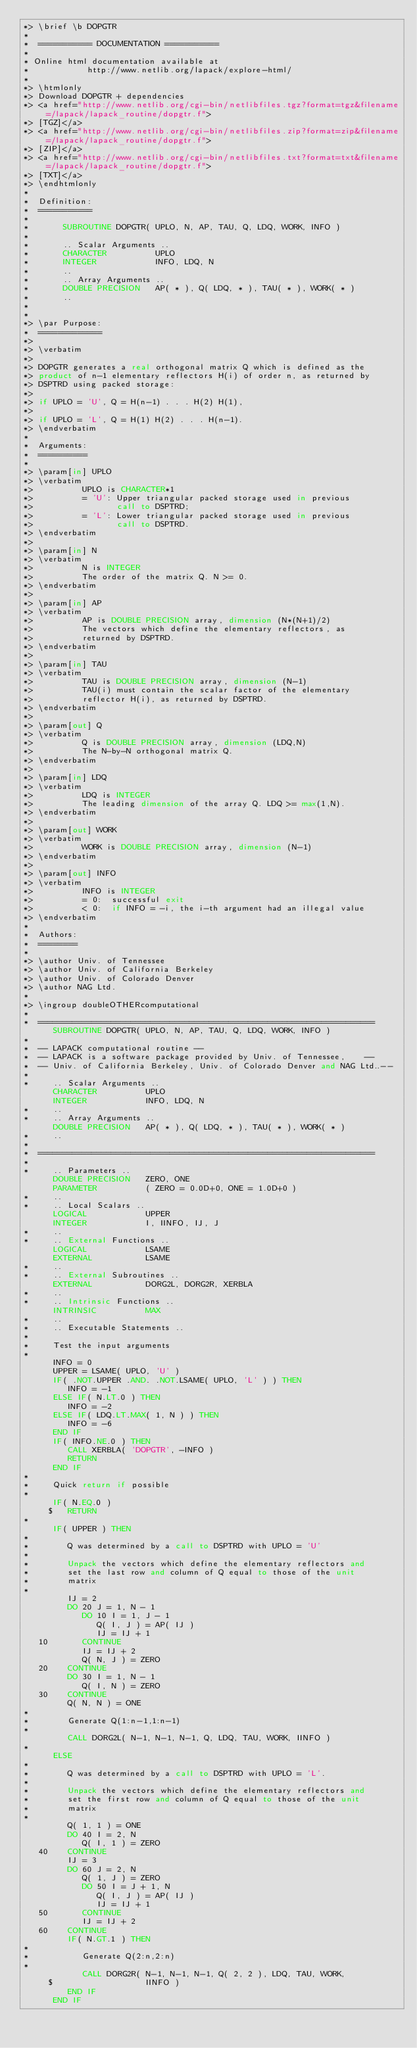Convert code to text. <code><loc_0><loc_0><loc_500><loc_500><_FORTRAN_>*> \brief \b DOPGTR
*
*  =========== DOCUMENTATION ===========
*
* Online html documentation available at
*            http://www.netlib.org/lapack/explore-html/
*
*> \htmlonly
*> Download DOPGTR + dependencies
*> <a href="http://www.netlib.org/cgi-bin/netlibfiles.tgz?format=tgz&filename=/lapack/lapack_routine/dopgtr.f">
*> [TGZ]</a>
*> <a href="http://www.netlib.org/cgi-bin/netlibfiles.zip?format=zip&filename=/lapack/lapack_routine/dopgtr.f">
*> [ZIP]</a>
*> <a href="http://www.netlib.org/cgi-bin/netlibfiles.txt?format=txt&filename=/lapack/lapack_routine/dopgtr.f">
*> [TXT]</a>
*> \endhtmlonly
*
*  Definition:
*  ===========
*
*       SUBROUTINE DOPGTR( UPLO, N, AP, TAU, Q, LDQ, WORK, INFO )
*
*       .. Scalar Arguments ..
*       CHARACTER          UPLO
*       INTEGER            INFO, LDQ, N
*       ..
*       .. Array Arguments ..
*       DOUBLE PRECISION   AP( * ), Q( LDQ, * ), TAU( * ), WORK( * )
*       ..
*
*
*> \par Purpose:
*  =============
*>
*> \verbatim
*>
*> DOPGTR generates a real orthogonal matrix Q which is defined as the
*> product of n-1 elementary reflectors H(i) of order n, as returned by
*> DSPTRD using packed storage:
*>
*> if UPLO = 'U', Q = H(n-1) . . . H(2) H(1),
*>
*> if UPLO = 'L', Q = H(1) H(2) . . . H(n-1).
*> \endverbatim
*
*  Arguments:
*  ==========
*
*> \param[in] UPLO
*> \verbatim
*>          UPLO is CHARACTER*1
*>          = 'U': Upper triangular packed storage used in previous
*>                 call to DSPTRD;
*>          = 'L': Lower triangular packed storage used in previous
*>                 call to DSPTRD.
*> \endverbatim
*>
*> \param[in] N
*> \verbatim
*>          N is INTEGER
*>          The order of the matrix Q. N >= 0.
*> \endverbatim
*>
*> \param[in] AP
*> \verbatim
*>          AP is DOUBLE PRECISION array, dimension (N*(N+1)/2)
*>          The vectors which define the elementary reflectors, as
*>          returned by DSPTRD.
*> \endverbatim
*>
*> \param[in] TAU
*> \verbatim
*>          TAU is DOUBLE PRECISION array, dimension (N-1)
*>          TAU(i) must contain the scalar factor of the elementary
*>          reflector H(i), as returned by DSPTRD.
*> \endverbatim
*>
*> \param[out] Q
*> \verbatim
*>          Q is DOUBLE PRECISION array, dimension (LDQ,N)
*>          The N-by-N orthogonal matrix Q.
*> \endverbatim
*>
*> \param[in] LDQ
*> \verbatim
*>          LDQ is INTEGER
*>          The leading dimension of the array Q. LDQ >= max(1,N).
*> \endverbatim
*>
*> \param[out] WORK
*> \verbatim
*>          WORK is DOUBLE PRECISION array, dimension (N-1)
*> \endverbatim
*>
*> \param[out] INFO
*> \verbatim
*>          INFO is INTEGER
*>          = 0:  successful exit
*>          < 0:  if INFO = -i, the i-th argument had an illegal value
*> \endverbatim
*
*  Authors:
*  ========
*
*> \author Univ. of Tennessee
*> \author Univ. of California Berkeley
*> \author Univ. of Colorado Denver
*> \author NAG Ltd.
*
*> \ingroup doubleOTHERcomputational
*
*  =====================================================================
      SUBROUTINE DOPGTR( UPLO, N, AP, TAU, Q, LDQ, WORK, INFO )
*
*  -- LAPACK computational routine --
*  -- LAPACK is a software package provided by Univ. of Tennessee,    --
*  -- Univ. of California Berkeley, Univ. of Colorado Denver and NAG Ltd..--
*
*     .. Scalar Arguments ..
      CHARACTER          UPLO
      INTEGER            INFO, LDQ, N
*     ..
*     .. Array Arguments ..
      DOUBLE PRECISION   AP( * ), Q( LDQ, * ), TAU( * ), WORK( * )
*     ..
*
*  =====================================================================
*
*     .. Parameters ..
      DOUBLE PRECISION   ZERO, ONE
      PARAMETER          ( ZERO = 0.0D+0, ONE = 1.0D+0 )
*     ..
*     .. Local Scalars ..
      LOGICAL            UPPER
      INTEGER            I, IINFO, IJ, J
*     ..
*     .. External Functions ..
      LOGICAL            LSAME
      EXTERNAL           LSAME
*     ..
*     .. External Subroutines ..
      EXTERNAL           DORG2L, DORG2R, XERBLA
*     ..
*     .. Intrinsic Functions ..
      INTRINSIC          MAX
*     ..
*     .. Executable Statements ..
*
*     Test the input arguments
*
      INFO = 0
      UPPER = LSAME( UPLO, 'U' )
      IF( .NOT.UPPER .AND. .NOT.LSAME( UPLO, 'L' ) ) THEN
         INFO = -1
      ELSE IF( N.LT.0 ) THEN
         INFO = -2
      ELSE IF( LDQ.LT.MAX( 1, N ) ) THEN
         INFO = -6
      END IF
      IF( INFO.NE.0 ) THEN
         CALL XERBLA( 'DOPGTR', -INFO )
         RETURN
      END IF
*
*     Quick return if possible
*
      IF( N.EQ.0 )
     $   RETURN
*
      IF( UPPER ) THEN
*
*        Q was determined by a call to DSPTRD with UPLO = 'U'
*
*        Unpack the vectors which define the elementary reflectors and
*        set the last row and column of Q equal to those of the unit
*        matrix
*
         IJ = 2
         DO 20 J = 1, N - 1
            DO 10 I = 1, J - 1
               Q( I, J ) = AP( IJ )
               IJ = IJ + 1
   10       CONTINUE
            IJ = IJ + 2
            Q( N, J ) = ZERO
   20    CONTINUE
         DO 30 I = 1, N - 1
            Q( I, N ) = ZERO
   30    CONTINUE
         Q( N, N ) = ONE
*
*        Generate Q(1:n-1,1:n-1)
*
         CALL DORG2L( N-1, N-1, N-1, Q, LDQ, TAU, WORK, IINFO )
*
      ELSE
*
*        Q was determined by a call to DSPTRD with UPLO = 'L'.
*
*        Unpack the vectors which define the elementary reflectors and
*        set the first row and column of Q equal to those of the unit
*        matrix
*
         Q( 1, 1 ) = ONE
         DO 40 I = 2, N
            Q( I, 1 ) = ZERO
   40    CONTINUE
         IJ = 3
         DO 60 J = 2, N
            Q( 1, J ) = ZERO
            DO 50 I = J + 1, N
               Q( I, J ) = AP( IJ )
               IJ = IJ + 1
   50       CONTINUE
            IJ = IJ + 2
   60    CONTINUE
         IF( N.GT.1 ) THEN
*
*           Generate Q(2:n,2:n)
*
            CALL DORG2R( N-1, N-1, N-1, Q( 2, 2 ), LDQ, TAU, WORK,
     $                   IINFO )
         END IF
      END IF</code> 